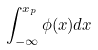<formula> <loc_0><loc_0><loc_500><loc_500>\int _ { - \infty } ^ { x _ { p } } \phi ( x ) d x</formula> 